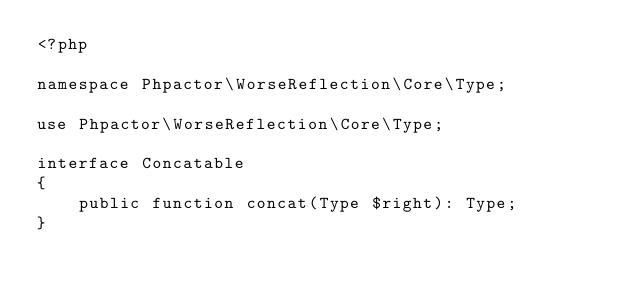<code> <loc_0><loc_0><loc_500><loc_500><_PHP_><?php

namespace Phpactor\WorseReflection\Core\Type;

use Phpactor\WorseReflection\Core\Type;

interface Concatable
{
    public function concat(Type $right): Type;
}
</code> 